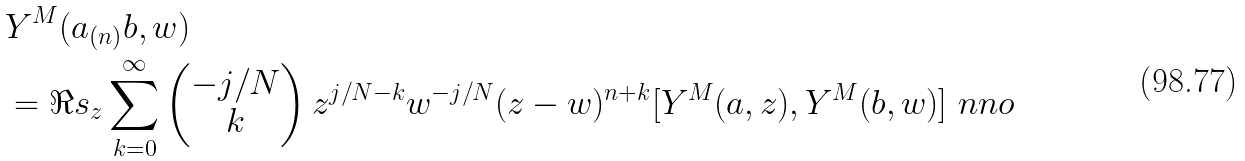Convert formula to latex. <formula><loc_0><loc_0><loc_500><loc_500>& Y ^ { M } ( a _ { ( n ) } b , w ) \\ & = \Re s _ { z } \sum _ { k = 0 } ^ { \infty } \begin{pmatrix} - j / N \\ k \end{pmatrix} z ^ { j / N - k } w ^ { - j / N } ( z - w ) ^ { n + k } [ Y ^ { M } ( a , z ) , Y ^ { M } ( b , w ) ] \ n n o</formula> 